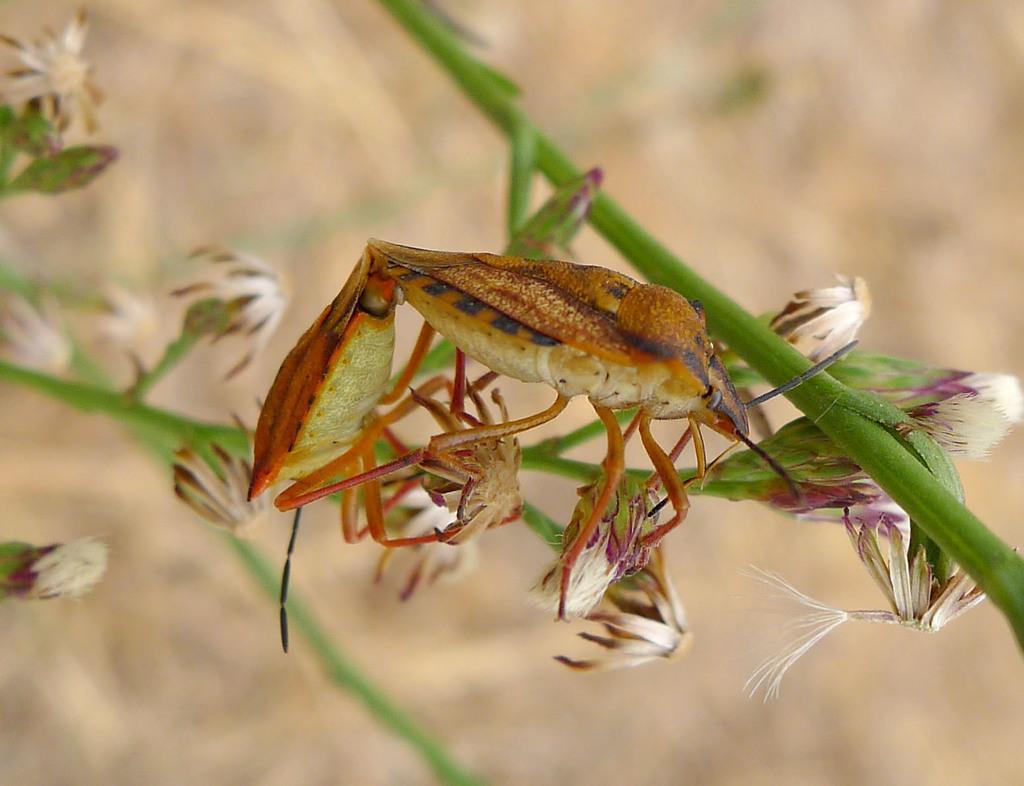Describe this image in one or two sentences. In this picture we can see an insect on a tree branch, flowers and in the background it is blurry. 